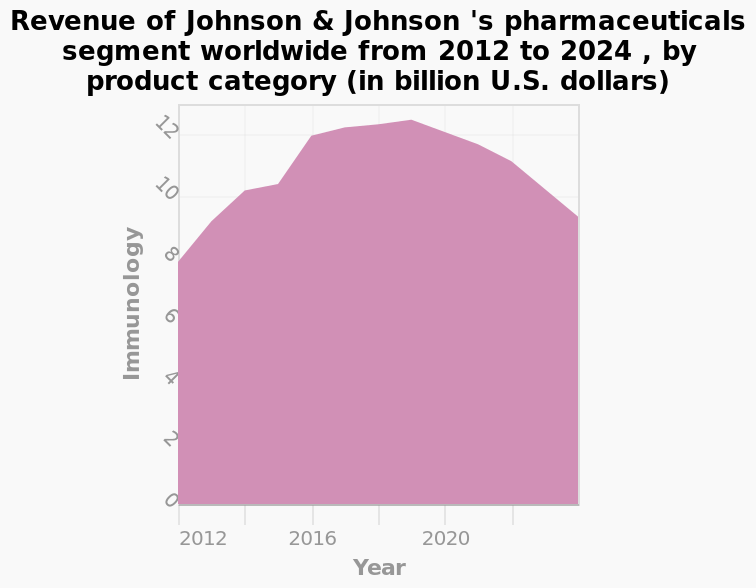<image>
What does the x-axis represent in the area plot?  The x-axis represents the years from 2012 to 2024. What is the scope of the data shown in the area plot? The area plot shows the revenue of Johnson & Johnson's pharmaceuticals segment worldwide from 2012 to 2024, specifically in the Immunology product category. please summary the statistics and relations of the chart From the chart it looks like j&j's pharmaceutical division has had a bumper year in 2020, obtaining over 12bn dollars in revenue, which is projected to reduce to around 10bn in 2024. This is still 2 bn higher than before 2020. 